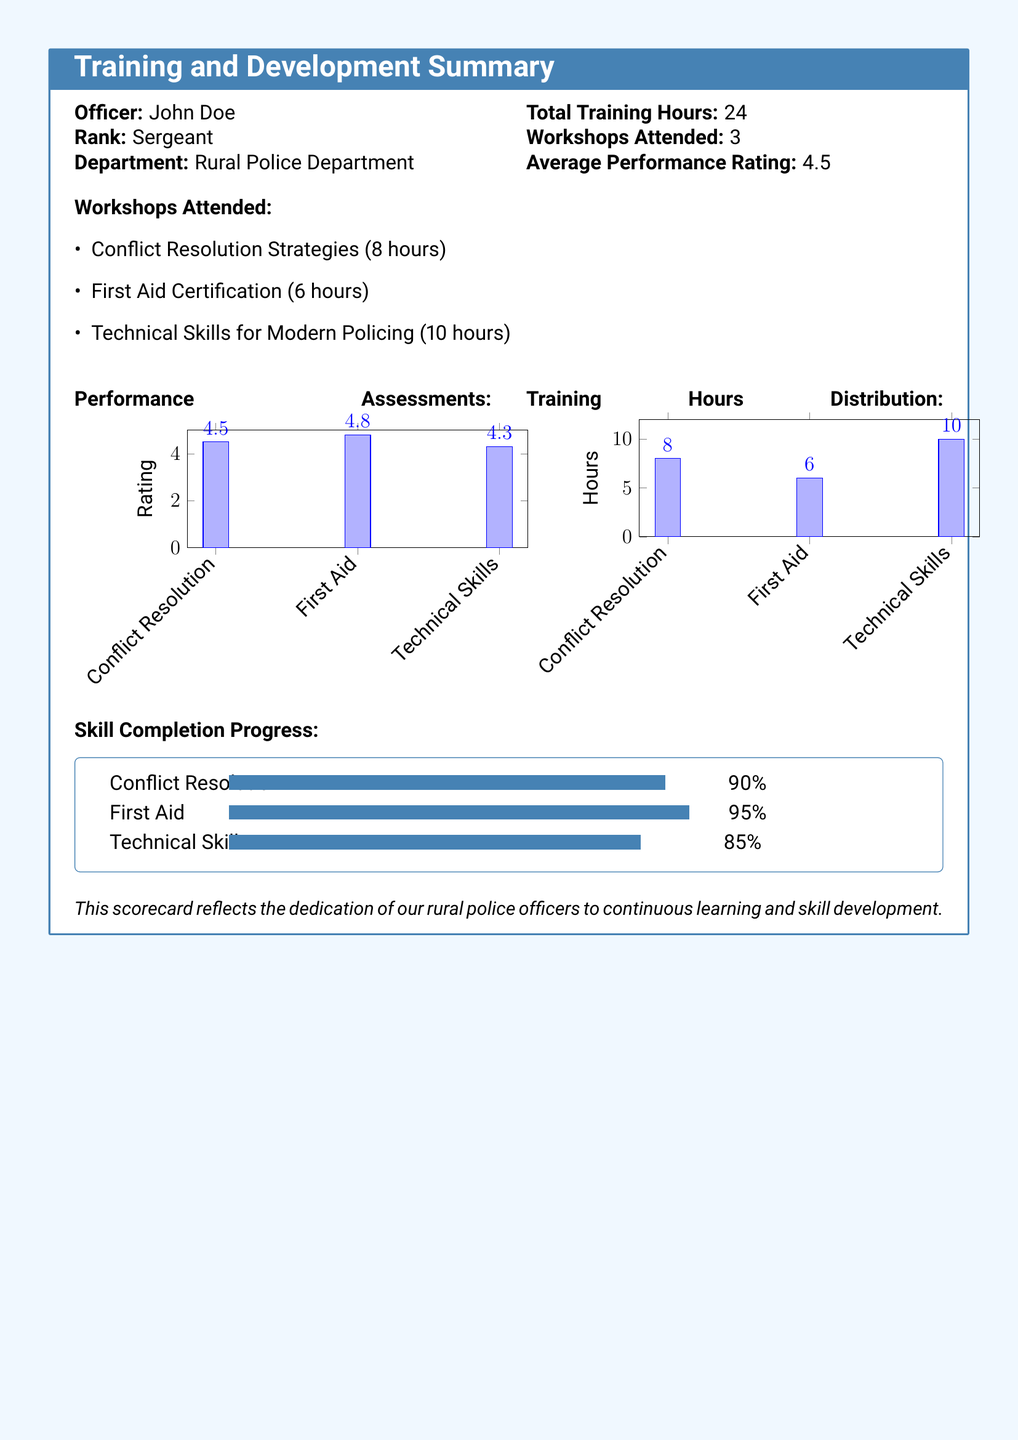what is the name of the officer? The officer's name is stated in the document as John Doe.
Answer: John Doe what is the total training hours completed? The total training hours completed are clearly stated in the document.
Answer: 24 how many workshops were attended? The number of workshops attended is listed in the summary section of the document.
Answer: 3 what is the average performance rating? The average performance rating is provided in the document summary.
Answer: 4.5 which workshop received the highest rating? The performance ratings for each workshop indicate which was rated the highest.
Answer: First Aid what percentage of completion is there for Technical Skills? The skill completion progress section shows this percentage explicitly.
Answer: 85% how many hours were spent on Conflict Resolution training? The training hours distribution section specifies the hours spent on this training.
Answer: 8 which workshop had the lowest performance rating? By comparing the performance assessments in the document, this can be determined.
Answer: Technical Skills what is the total number of hours spent on First Aid training? The document includes specific hours for each workshop, including First Aid.
Answer: 6 